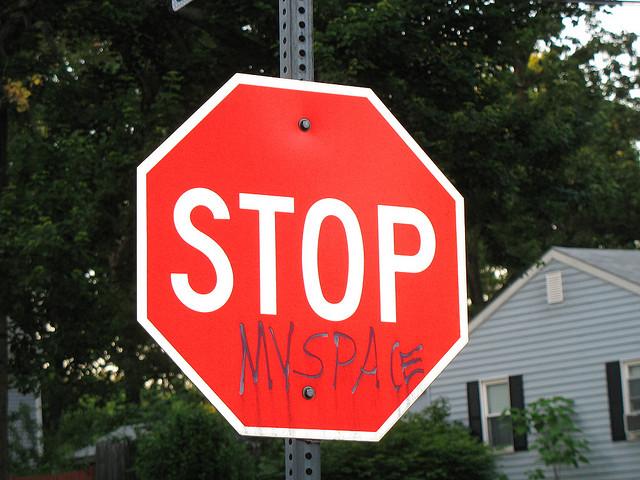What color are the shutters?
Give a very brief answer. Black. What does the graffiti say?
Short answer required. Myspace. What do you think is behind the bushes?
Answer briefly. House. 